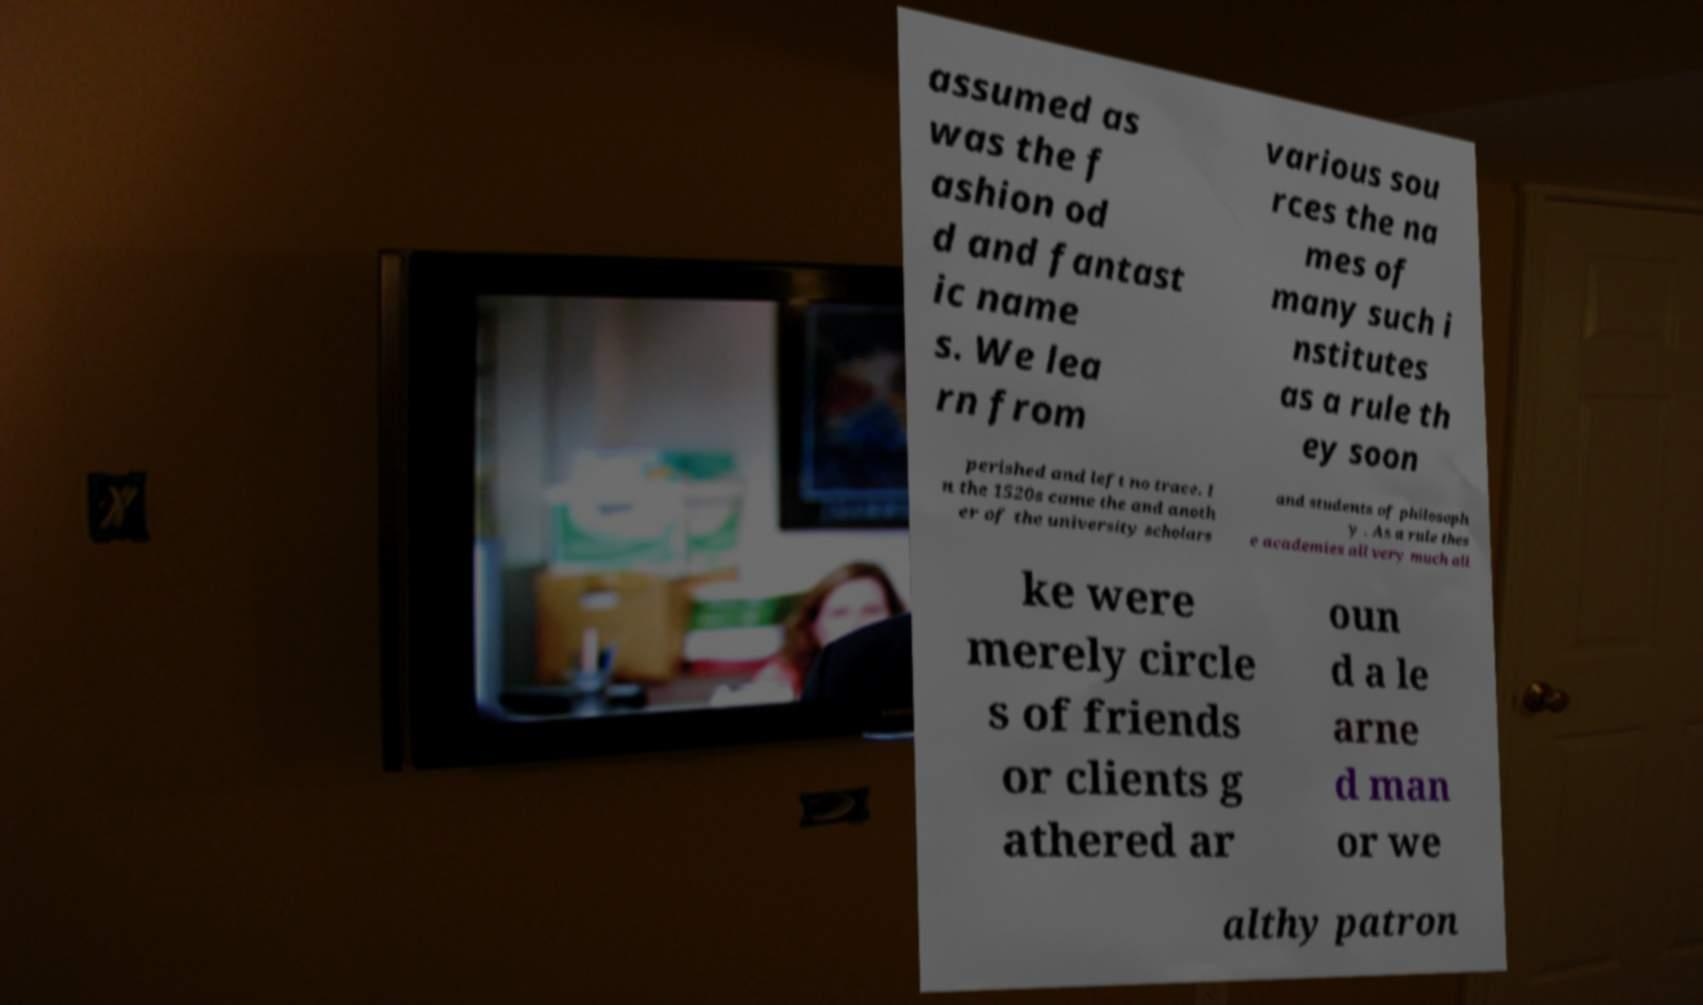For documentation purposes, I need the text within this image transcribed. Could you provide that? assumed as was the f ashion od d and fantast ic name s. We lea rn from various sou rces the na mes of many such i nstitutes as a rule th ey soon perished and left no trace. I n the 1520s came the and anoth er of the university scholars and students of philosoph y . As a rule thes e academies all very much ali ke were merely circle s of friends or clients g athered ar oun d a le arne d man or we althy patron 